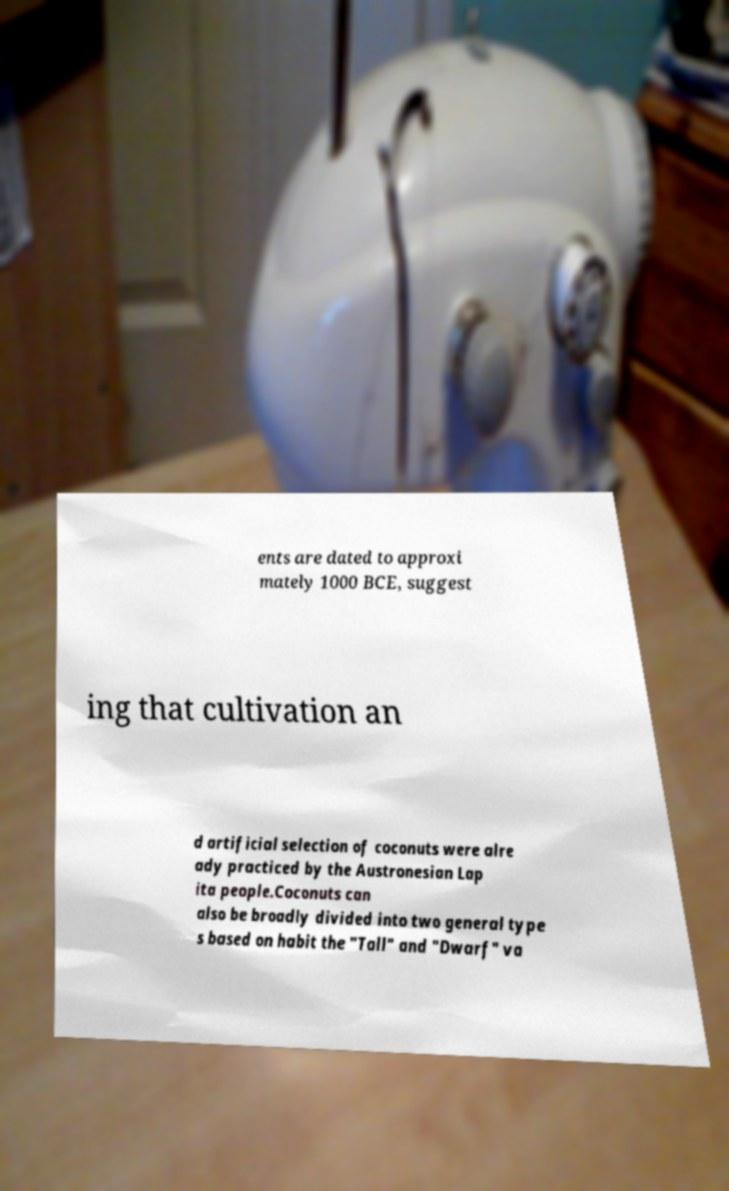Could you assist in decoding the text presented in this image and type it out clearly? ents are dated to approxi mately 1000 BCE, suggest ing that cultivation an d artificial selection of coconuts were alre ady practiced by the Austronesian Lap ita people.Coconuts can also be broadly divided into two general type s based on habit the "Tall" and "Dwarf" va 